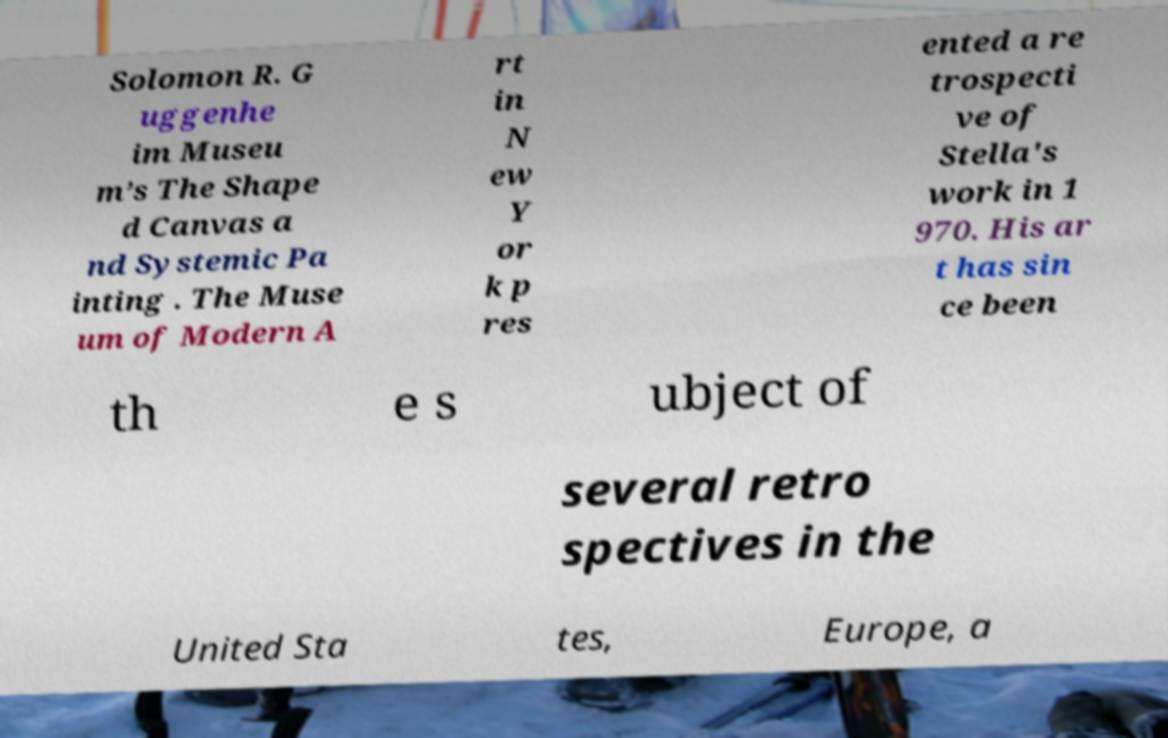Can you read and provide the text displayed in the image?This photo seems to have some interesting text. Can you extract and type it out for me? Solomon R. G uggenhe im Museu m’s The Shape d Canvas a nd Systemic Pa inting . The Muse um of Modern A rt in N ew Y or k p res ented a re trospecti ve of Stella's work in 1 970. His ar t has sin ce been th e s ubject of several retro spectives in the United Sta tes, Europe, a 